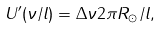Convert formula to latex. <formula><loc_0><loc_0><loc_500><loc_500>U ^ { \prime } ( \nu / l ) = \Delta \nu 2 \pi R _ { \odot } / l ,</formula> 